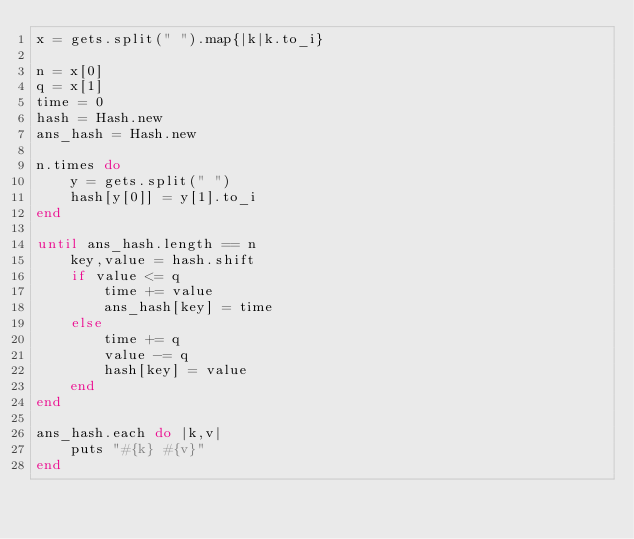Convert code to text. <code><loc_0><loc_0><loc_500><loc_500><_Ruby_>x = gets.split(" ").map{|k|k.to_i}

n = x[0]
q = x[1]
time = 0
hash = Hash.new
ans_hash = Hash.new

n.times do
    y = gets.split(" ")
    hash[y[0]] = y[1].to_i
end

until ans_hash.length == n
    key,value = hash.shift
    if value <= q
        time += value
        ans_hash[key] = time
    else
        time += q
        value -= q
        hash[key] = value
    end
end

ans_hash.each do |k,v|
    puts "#{k} #{v}"
end
</code> 